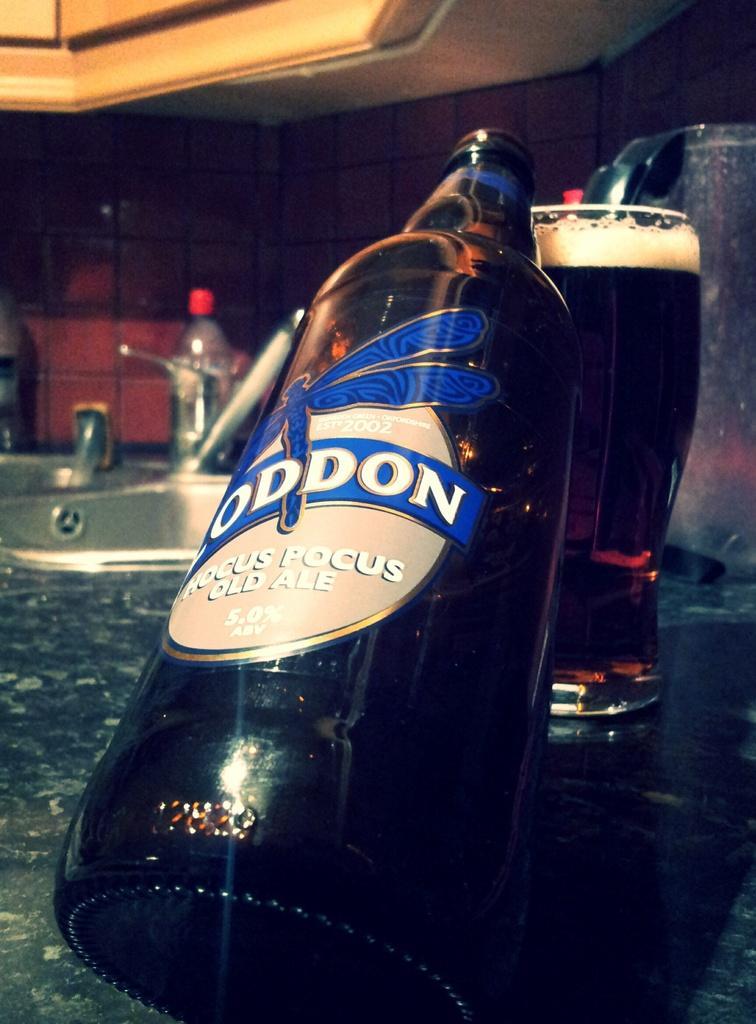Can you describe this image briefly? This picture is consists of a bottle which is placed which is placed on a glass and there is a glass at the right side of the image, contains drink in it. 